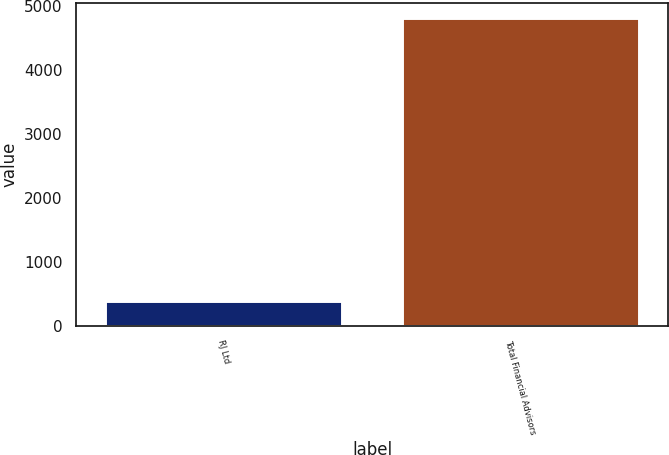Convert chart. <chart><loc_0><loc_0><loc_500><loc_500><bar_chart><fcel>RJ Ltd<fcel>Total Financial Advisors<nl><fcel>391<fcel>4809<nl></chart> 